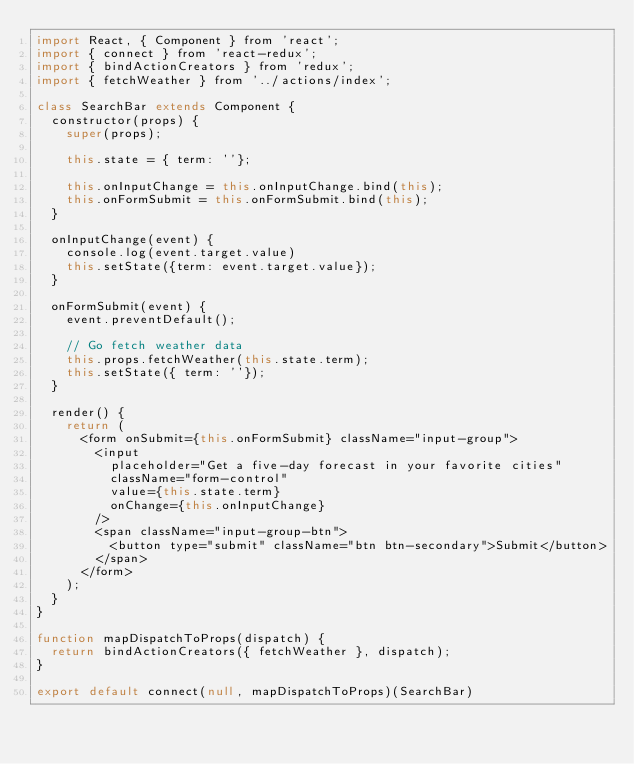<code> <loc_0><loc_0><loc_500><loc_500><_JavaScript_>import React, { Component } from 'react';
import { connect } from 'react-redux';
import { bindActionCreators } from 'redux';
import { fetchWeather } from '../actions/index';

class SearchBar extends Component {
  constructor(props) {
    super(props);

    this.state = { term: ''};

    this.onInputChange = this.onInputChange.bind(this);
    this.onFormSubmit = this.onFormSubmit.bind(this);
  }

  onInputChange(event) {
    console.log(event.target.value)
    this.setState({term: event.target.value});
  }

  onFormSubmit(event) {
    event.preventDefault();

    // Go fetch weather data
    this.props.fetchWeather(this.state.term);
    this.setState({ term: ''});
  }

  render() {
    return (
      <form onSubmit={this.onFormSubmit} className="input-group">
        <input
          placeholder="Get a five-day forecast in your favorite cities"
          className="form-control"
          value={this.state.term}
          onChange={this.onInputChange}
        />
        <span className="input-group-btn">
          <button type="submit" className="btn btn-secondary">Submit</button>
        </span>
      </form>
    );
  }
}

function mapDispatchToProps(dispatch) {
  return bindActionCreators({ fetchWeather }, dispatch);
}

export default connect(null, mapDispatchToProps)(SearchBar)
</code> 